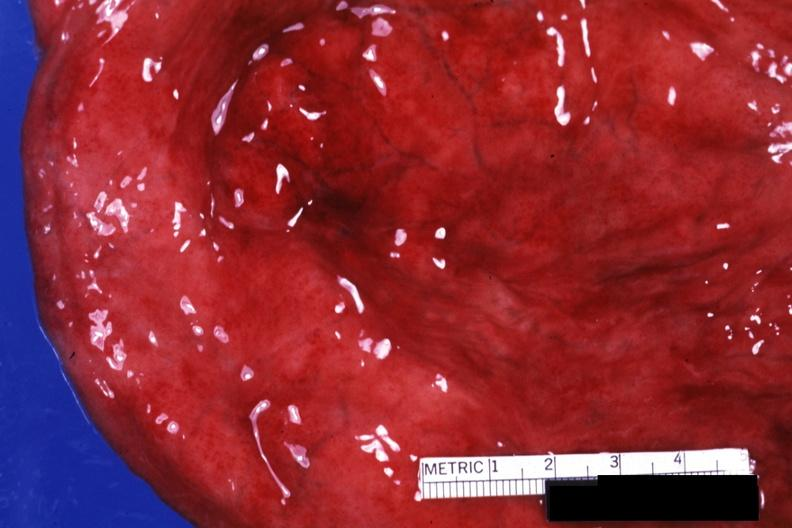what is present?
Answer the question using a single word or phrase. Hemorrhagic cystitis 